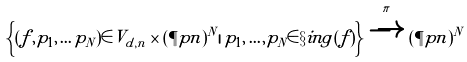Convert formula to latex. <formula><loc_0><loc_0><loc_500><loc_500>\left \{ ( f , p _ { 1 } , \dots p _ { N } ) \in V _ { d , n } \times ( \P p n ) ^ { N } | \, p _ { 1 } , \dots , p _ { N } \in \S i n g ( f ) \right \} \xrightarrow { \pi } ( \P p n ) ^ { N }</formula> 